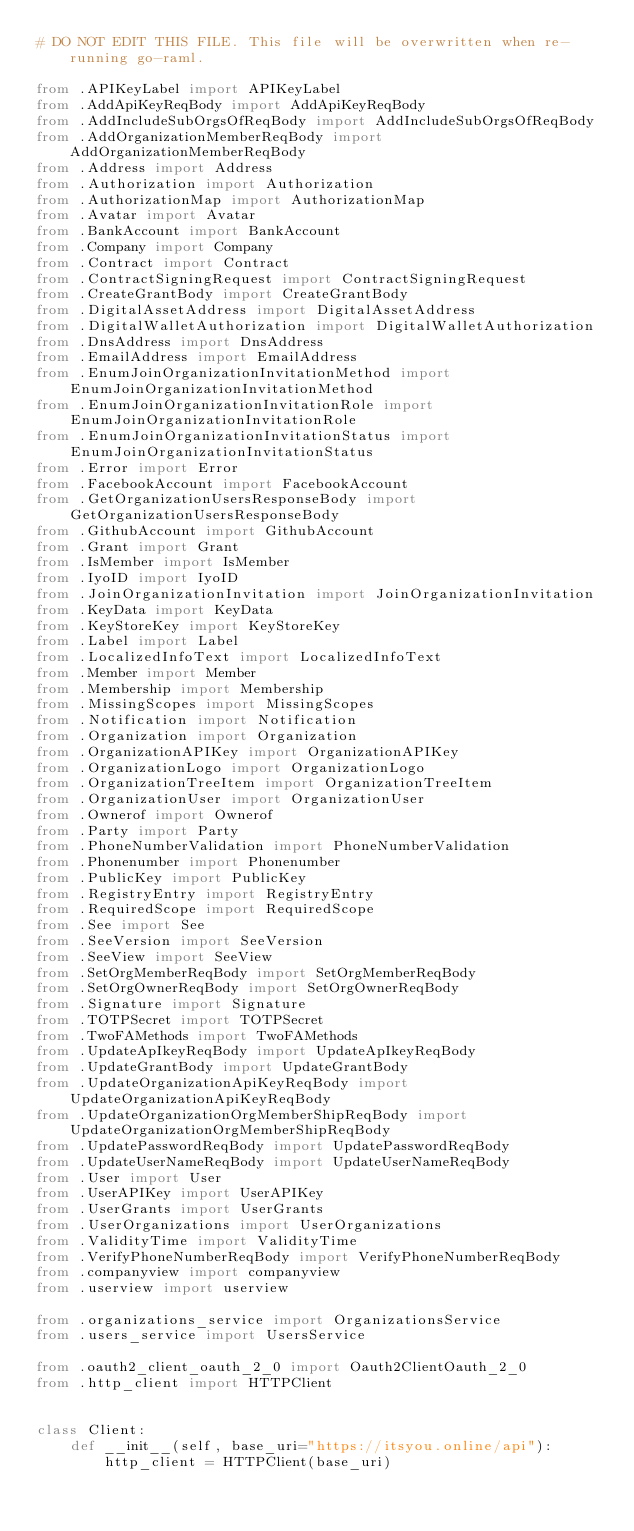<code> <loc_0><loc_0><loc_500><loc_500><_Python_># DO NOT EDIT THIS FILE. This file will be overwritten when re-running go-raml.

from .APIKeyLabel import APIKeyLabel
from .AddApiKeyReqBody import AddApiKeyReqBody
from .AddIncludeSubOrgsOfReqBody import AddIncludeSubOrgsOfReqBody
from .AddOrganizationMemberReqBody import AddOrganizationMemberReqBody
from .Address import Address
from .Authorization import Authorization
from .AuthorizationMap import AuthorizationMap
from .Avatar import Avatar
from .BankAccount import BankAccount
from .Company import Company
from .Contract import Contract
from .ContractSigningRequest import ContractSigningRequest
from .CreateGrantBody import CreateGrantBody
from .DigitalAssetAddress import DigitalAssetAddress
from .DigitalWalletAuthorization import DigitalWalletAuthorization
from .DnsAddress import DnsAddress
from .EmailAddress import EmailAddress
from .EnumJoinOrganizationInvitationMethod import EnumJoinOrganizationInvitationMethod
from .EnumJoinOrganizationInvitationRole import EnumJoinOrganizationInvitationRole
from .EnumJoinOrganizationInvitationStatus import EnumJoinOrganizationInvitationStatus
from .Error import Error
from .FacebookAccount import FacebookAccount
from .GetOrganizationUsersResponseBody import GetOrganizationUsersResponseBody
from .GithubAccount import GithubAccount
from .Grant import Grant
from .IsMember import IsMember
from .IyoID import IyoID
from .JoinOrganizationInvitation import JoinOrganizationInvitation
from .KeyData import KeyData
from .KeyStoreKey import KeyStoreKey
from .Label import Label
from .LocalizedInfoText import LocalizedInfoText
from .Member import Member
from .Membership import Membership
from .MissingScopes import MissingScopes
from .Notification import Notification
from .Organization import Organization
from .OrganizationAPIKey import OrganizationAPIKey
from .OrganizationLogo import OrganizationLogo
from .OrganizationTreeItem import OrganizationTreeItem
from .OrganizationUser import OrganizationUser
from .Ownerof import Ownerof
from .Party import Party
from .PhoneNumberValidation import PhoneNumberValidation
from .Phonenumber import Phonenumber
from .PublicKey import PublicKey
from .RegistryEntry import RegistryEntry
from .RequiredScope import RequiredScope
from .See import See
from .SeeVersion import SeeVersion
from .SeeView import SeeView
from .SetOrgMemberReqBody import SetOrgMemberReqBody
from .SetOrgOwnerReqBody import SetOrgOwnerReqBody
from .Signature import Signature
from .TOTPSecret import TOTPSecret
from .TwoFAMethods import TwoFAMethods
from .UpdateApIkeyReqBody import UpdateApIkeyReqBody
from .UpdateGrantBody import UpdateGrantBody
from .UpdateOrganizationApiKeyReqBody import UpdateOrganizationApiKeyReqBody
from .UpdateOrganizationOrgMemberShipReqBody import UpdateOrganizationOrgMemberShipReqBody
from .UpdatePasswordReqBody import UpdatePasswordReqBody
from .UpdateUserNameReqBody import UpdateUserNameReqBody
from .User import User
from .UserAPIKey import UserAPIKey
from .UserGrants import UserGrants
from .UserOrganizations import UserOrganizations
from .ValidityTime import ValidityTime
from .VerifyPhoneNumberReqBody import VerifyPhoneNumberReqBody
from .companyview import companyview
from .userview import userview

from .organizations_service import OrganizationsService
from .users_service import UsersService

from .oauth2_client_oauth_2_0 import Oauth2ClientOauth_2_0
from .http_client import HTTPClient


class Client:
    def __init__(self, base_uri="https://itsyou.online/api"):
        http_client = HTTPClient(base_uri)</code> 